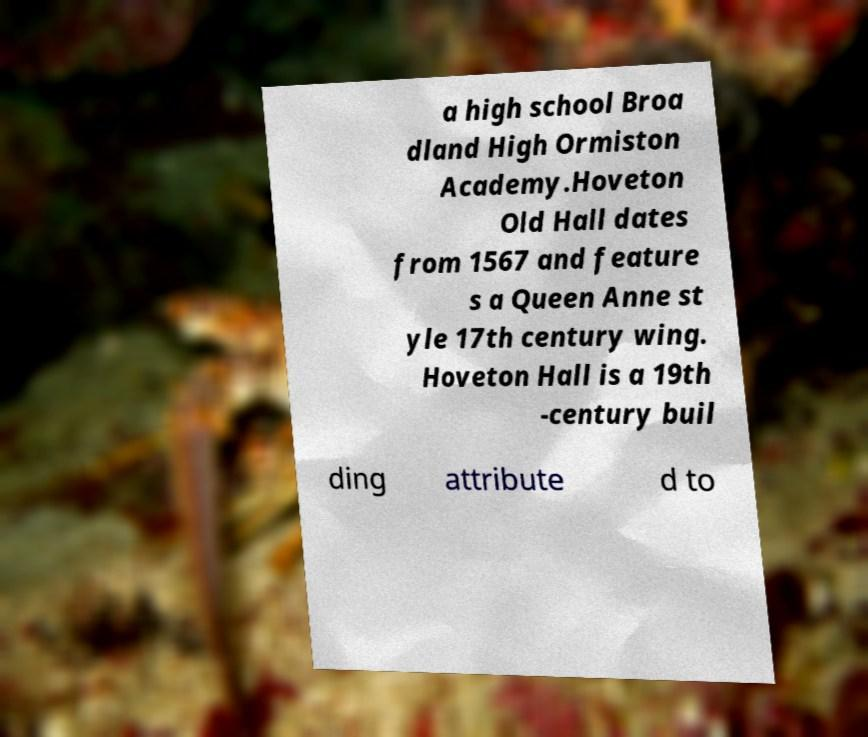Please read and relay the text visible in this image. What does it say? a high school Broa dland High Ormiston Academy.Hoveton Old Hall dates from 1567 and feature s a Queen Anne st yle 17th century wing. Hoveton Hall is a 19th -century buil ding attribute d to 